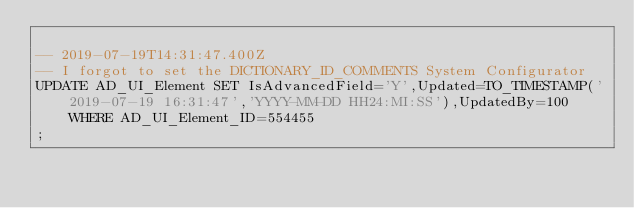<code> <loc_0><loc_0><loc_500><loc_500><_SQL_>
-- 2019-07-19T14:31:47.400Z
-- I forgot to set the DICTIONARY_ID_COMMENTS System Configurator
UPDATE AD_UI_Element SET IsAdvancedField='Y',Updated=TO_TIMESTAMP('2019-07-19 16:31:47','YYYY-MM-DD HH24:MI:SS'),UpdatedBy=100 WHERE AD_UI_Element_ID=554455
;

</code> 